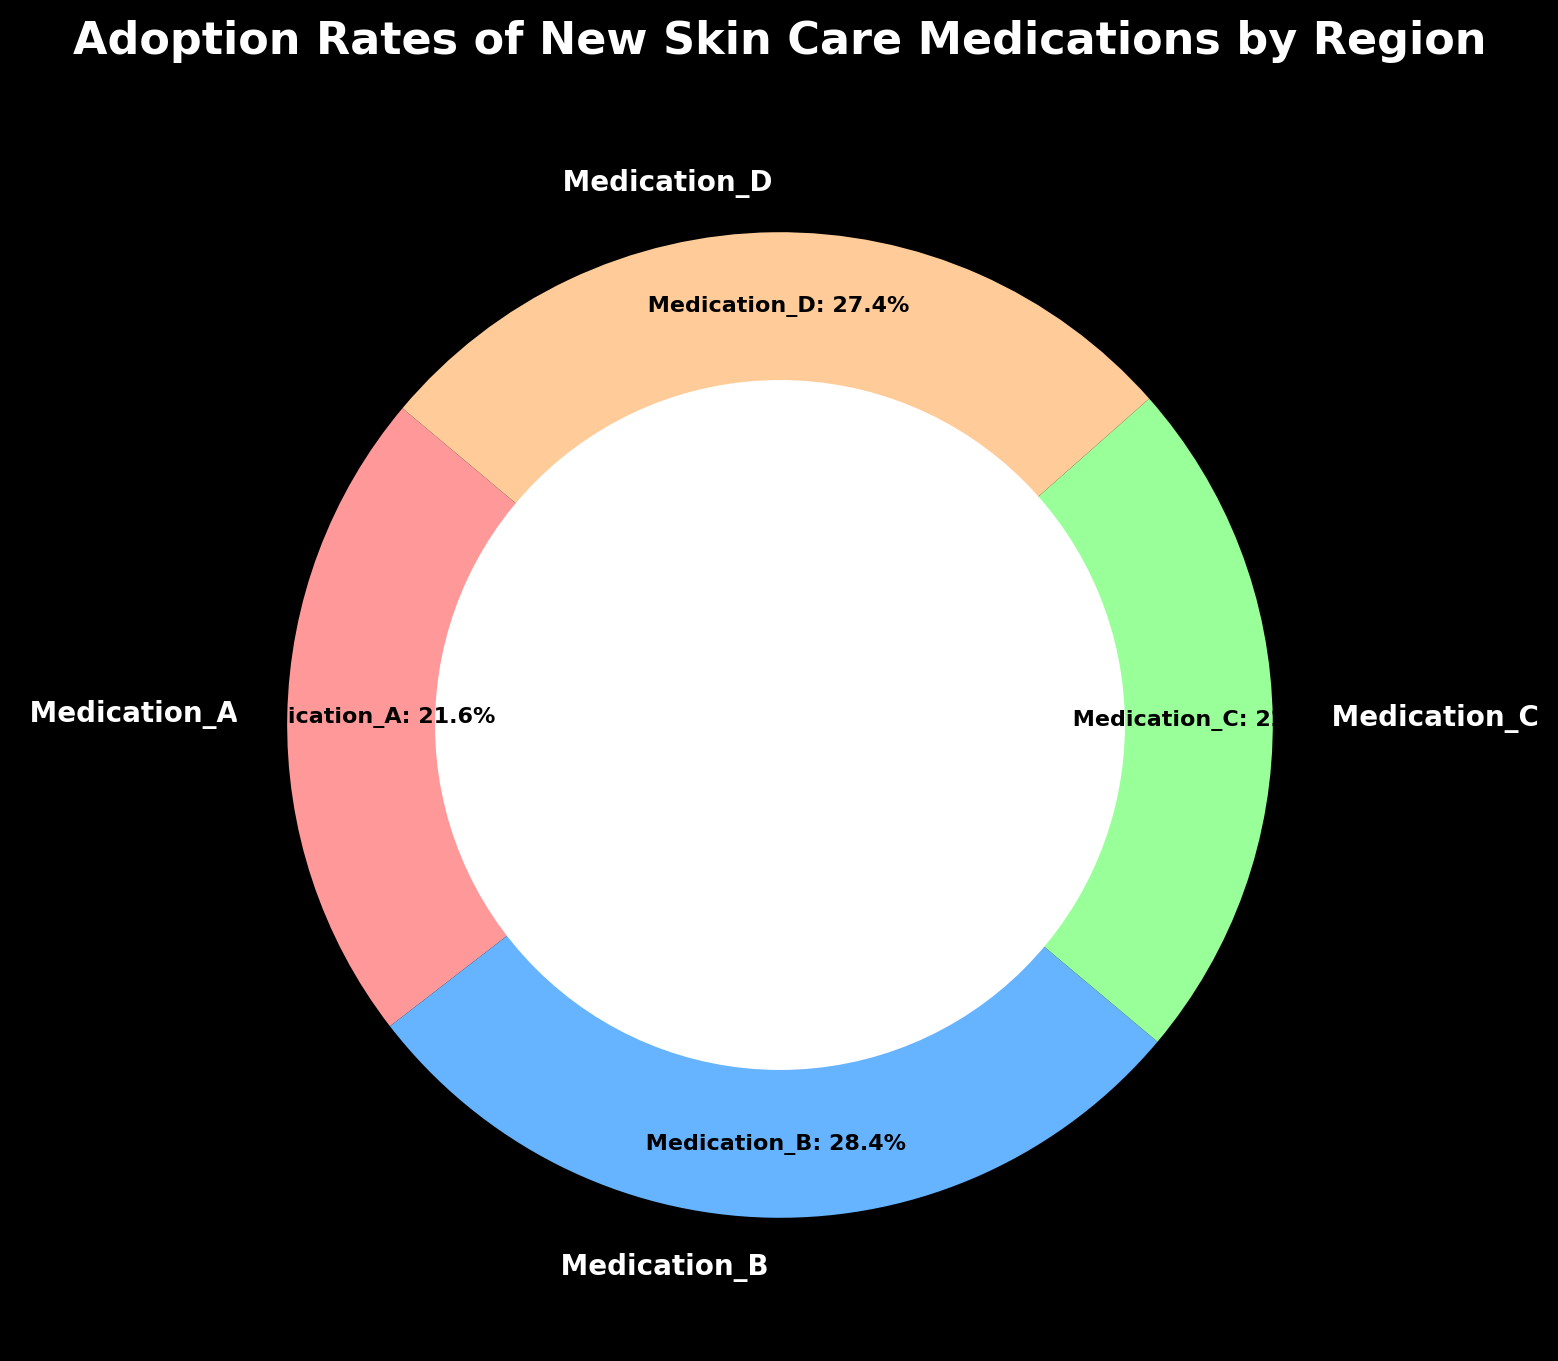Which medication has the highest adoption rate? Refer to the percentage labels around the ring chart. The medication with the highest percentage has the highest adoption rate.
Answer: Medication_B Which region has the lowest adoption rates across all medications? Sum up the adoption rates for each region from the data table and compare. South America has the lowest total adoption rate.
Answer: South America Which medication has the smallest percentage in the ring chart? Look at the smallest percentage label around the ring chart.
Answer: Medication_C How much higher is the adoption rate of Medication_B compared to Medication_D? Find the percentages for Medication_B and Medication_D in the ring chart and subtract the smaller percentage from the larger one. Medication_B is higher by (55% - 45%) = 10%.
Answer: 10% What is the total adoption percentage for the medications with the highest and lowest adoption rates? Identify the highest and lowest percentages in the chart, then add these two values together. Medication_B (55%) + Medication_C (25%) = 80%.
Answer: 80% If Medication_A is represented by the red segment, what percentage of the total adoption does it hold? Find the label corresponding to Medication_A, which is represented by the red segment, on the ring chart.
Answer: 22.8% How much more is the total adoption rate in Oceania compared to Africa? Add the adoption rates of all medications for both Oceania and Africa from the data table. Oceania: 30 + 40 + 35 + 45 = 150. Africa: 20 + 30 + 25 + 30 = 105. Difference: 150 - 105 = 45.
Answer: 45 What is the difference in adoption rates of Medication_A between North America and Europe? Subtract the adoption rate of Medication_A in Europe from that in North America (50 - 45).
Answer: 5% 